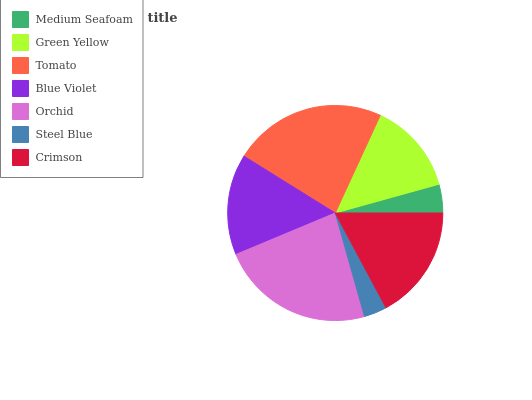Is Steel Blue the minimum?
Answer yes or no. Yes. Is Orchid the maximum?
Answer yes or no. Yes. Is Green Yellow the minimum?
Answer yes or no. No. Is Green Yellow the maximum?
Answer yes or no. No. Is Green Yellow greater than Medium Seafoam?
Answer yes or no. Yes. Is Medium Seafoam less than Green Yellow?
Answer yes or no. Yes. Is Medium Seafoam greater than Green Yellow?
Answer yes or no. No. Is Green Yellow less than Medium Seafoam?
Answer yes or no. No. Is Blue Violet the high median?
Answer yes or no. Yes. Is Blue Violet the low median?
Answer yes or no. Yes. Is Crimson the high median?
Answer yes or no. No. Is Tomato the low median?
Answer yes or no. No. 